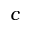<formula> <loc_0><loc_0><loc_500><loc_500>c</formula> 